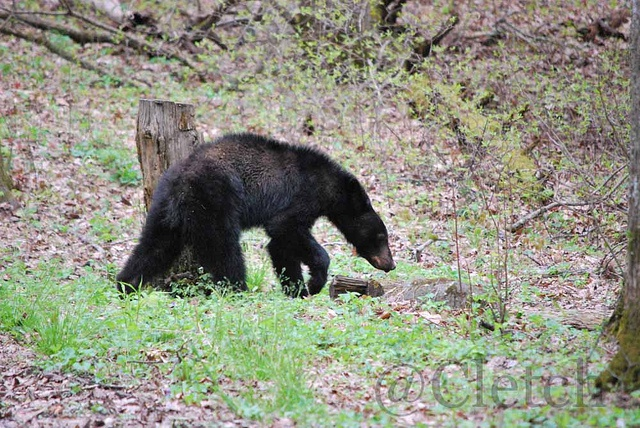Describe the objects in this image and their specific colors. I can see a bear in gray, black, and darkgray tones in this image. 